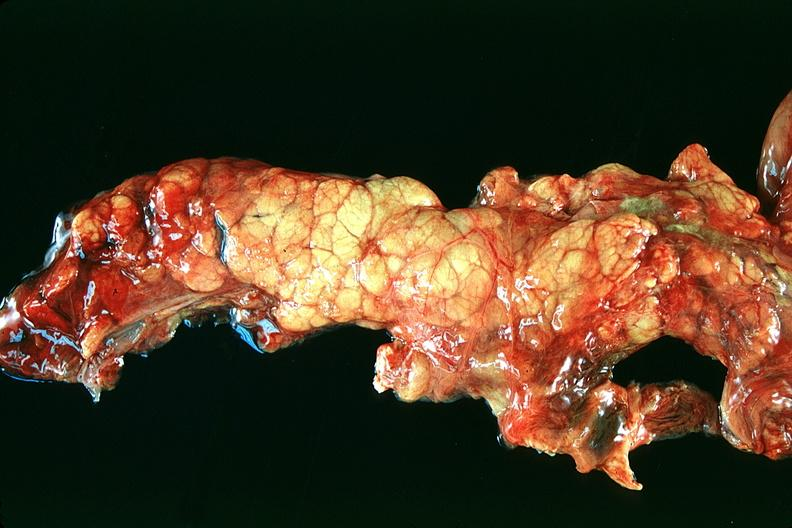does polycystic disease show normal pancreas?
Answer the question using a single word or phrase. No 